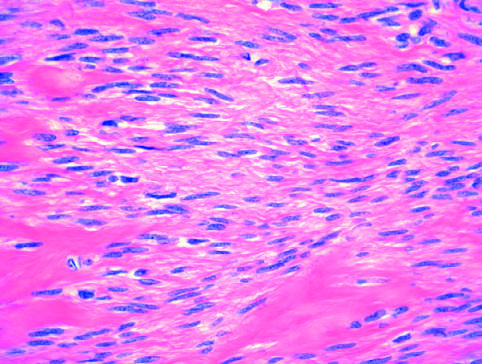what does the microscopic appearance of leiomyoma show?
Answer the question using a single word or phrase. Bundles of normal-looking smooth muscle cells 